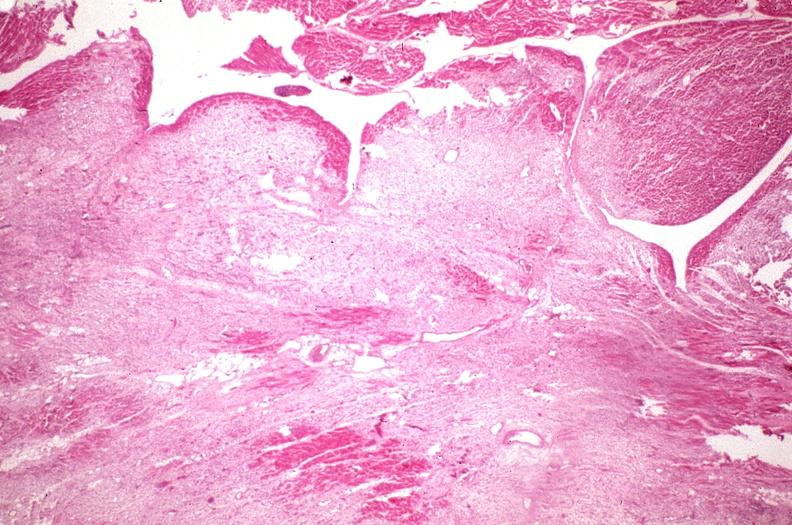what does this image show?
Answer the question using a single word or phrase. Heart 